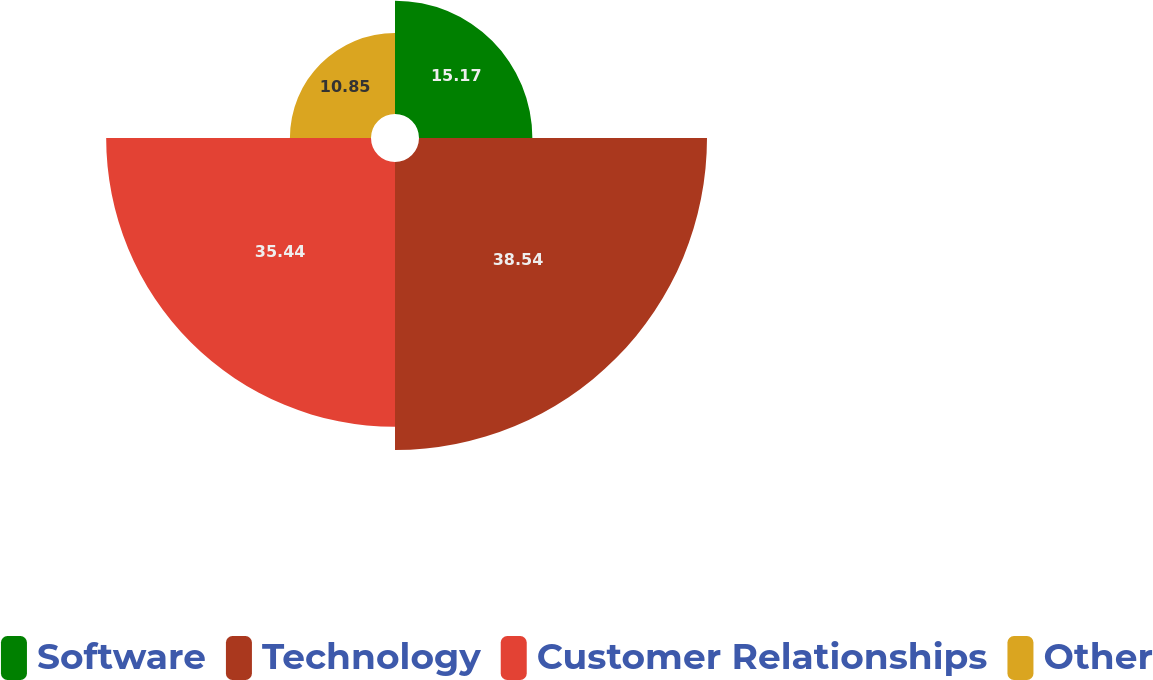<chart> <loc_0><loc_0><loc_500><loc_500><pie_chart><fcel>Software<fcel>Technology<fcel>Customer Relationships<fcel>Other<nl><fcel>15.17%<fcel>38.54%<fcel>35.44%<fcel>10.85%<nl></chart> 